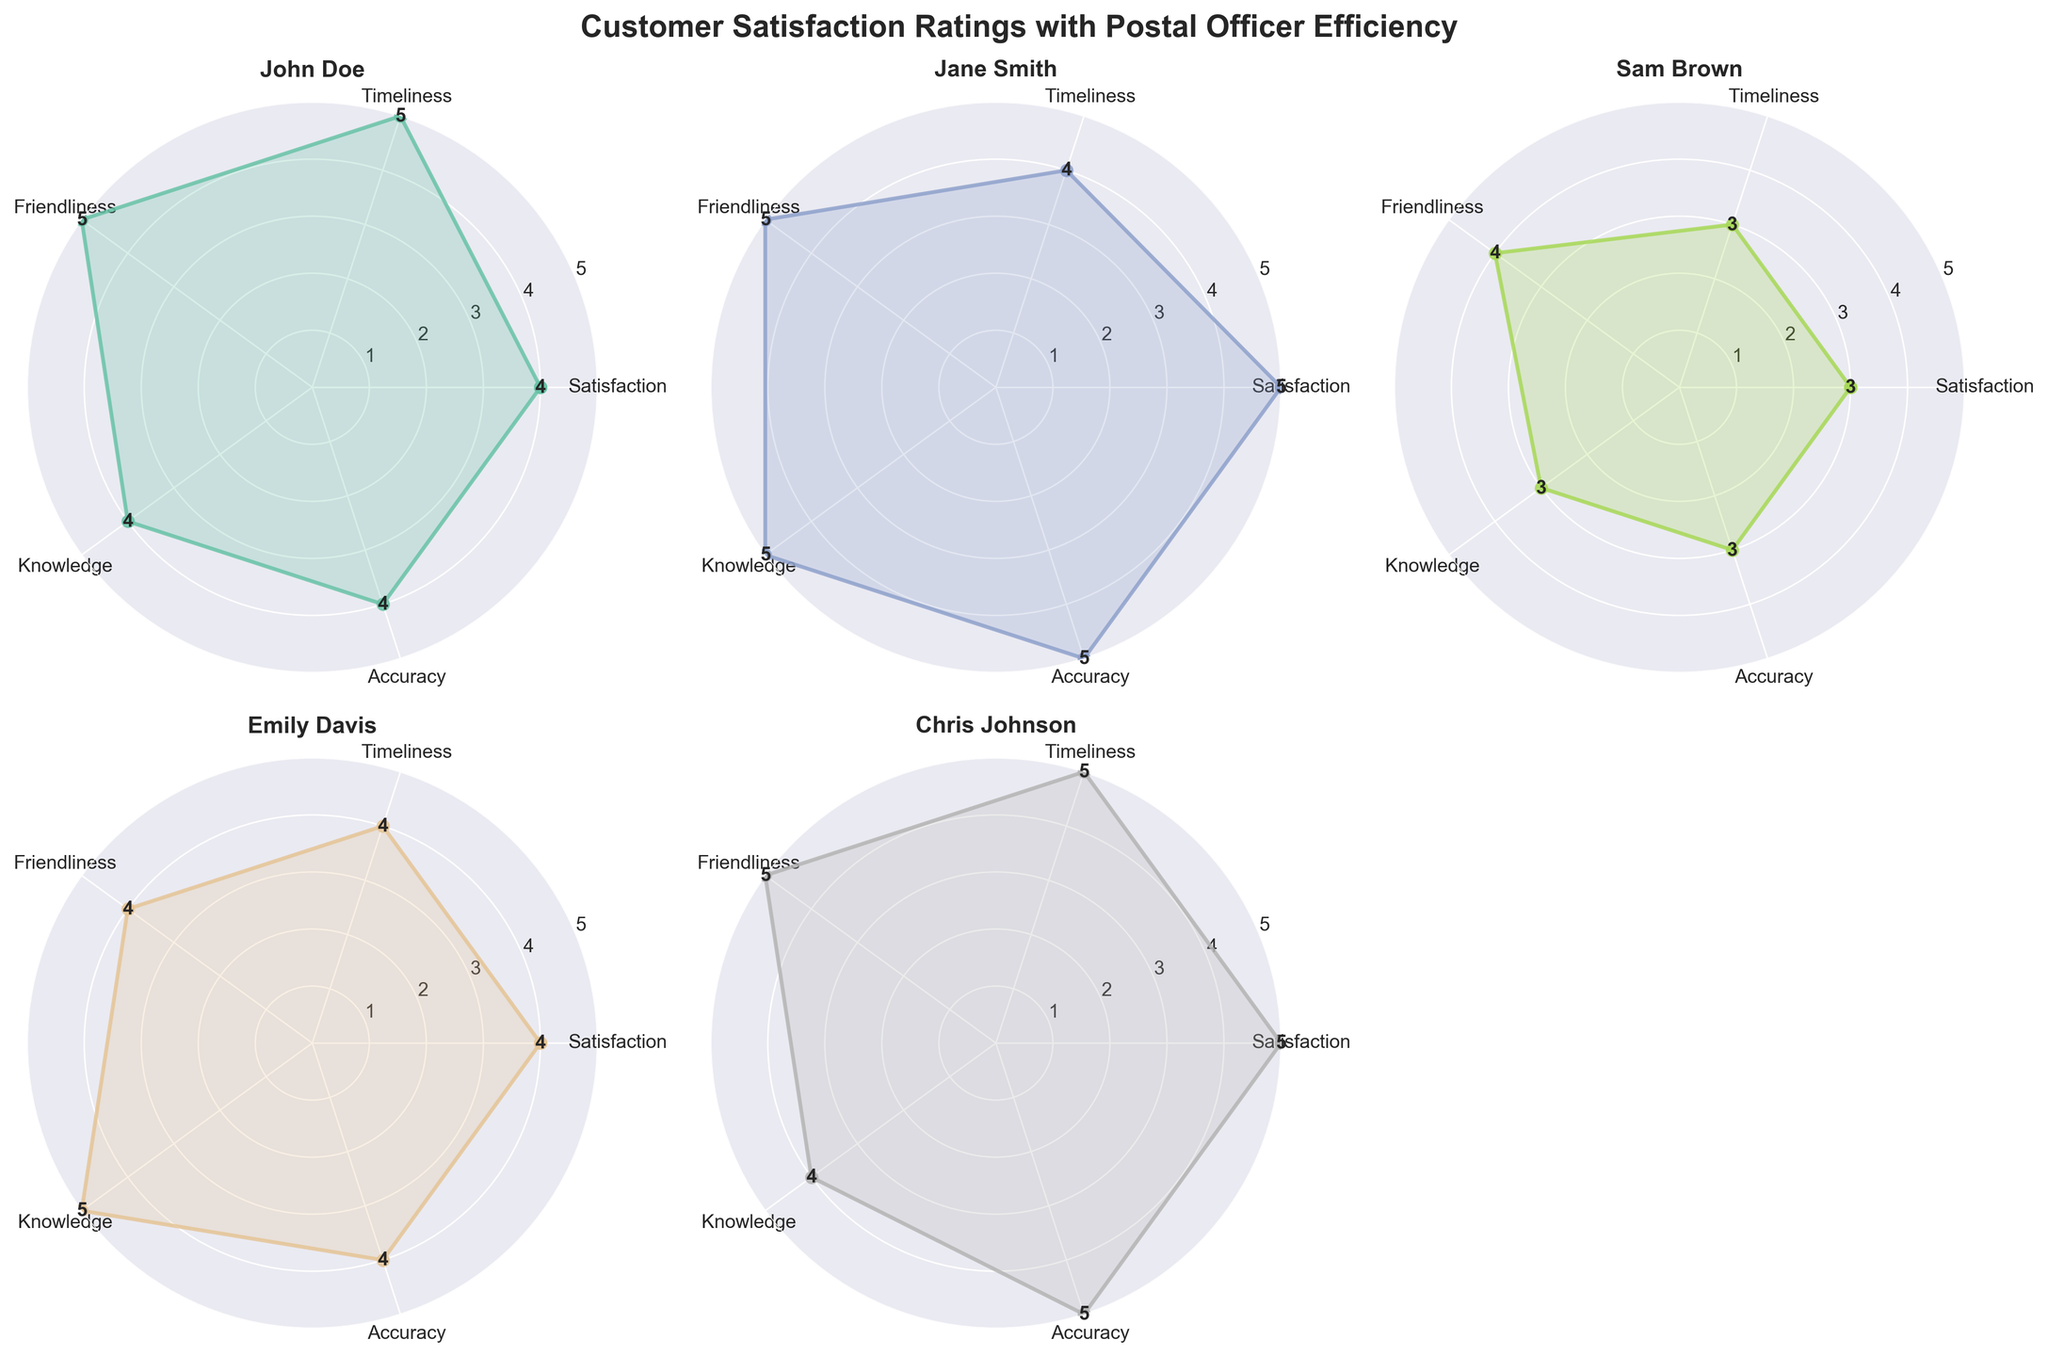What is the title of the figure? The title of the figure is found at the top of the entire plot. In this case, it reads "Customer Satisfaction Ratings with Postal Officer Efficiency".
Answer: Customer Satisfaction Ratings with Postal Officer Efficiency How many customers' ratings are displayed in the figure? By counting the number of radar charts present in the figure, we determine that there are 5 individual radar charts, each representing a different customer.
Answer: 5 Which customer gave the highest rating in Knowledge? The individual values of the Knowledge category can be read directly from each radar chart. Jane Smith rated the Knowledge category with a perfect score of 5.
Answer: Jane Smith Who gave the lowest rating for Timeliness? By analyzing the Timeliness values in each radar chart, Sam Brown provided the lowest rating of 3.
Answer: Sam Brown What is the average Satisfaction score across all customers? To find the average of Satisfaction scores, sum the numbers 4, 5, 3, 4, and 5, then divide by the number of ratings: (4 + 5 + 3 + 4 + 5) / 5 = 21 / 5 = 4.2
Answer: 4.2 Which customer has the most balanced ratings across all categories? A balanced rating is indicated by values that are roughly equal across the categories. Chris Johnson has values of 5, 5, 5, 4, and 5, which are quite balanced.
Answer: Chris Johnson Compare the satisfaction score of Emily Davis and Chris Johnson. Who rated higher? By comparing the values in the Satisfaction category of both customers, Chris Johnson rated higher with a score of 5 compared to Emily Davis’s score of 4.
Answer: Chris Johnson What is the difference in Friendliness rating between John Doe and Sam Brown? The Friendliness ratings for John Doe and Sam Brown are 5 and 4 respectively. The difference is 5 - 4 = 1.
Answer: 1 Between Jane Smith and Emily Davis, who rated the postal officer’s timeliness lower? By analyzing the Timeliness values, Jane Smith rated Timeliness 4, while Emily Davis rated it at 4 as well. They both gave the same rating.
Answer: They rated equally What is the overall trend in Accuracy ratings across all customers? Observing the Accuracy ratings in all radar charts, the values are generally high: 4, 5, 3, 4, and 5. This indicates that most customers are highly satisfied with the accuracy of the postal officer.
Answer: Generally high 